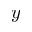Convert formula to latex. <formula><loc_0><loc_0><loc_500><loc_500>y</formula> 